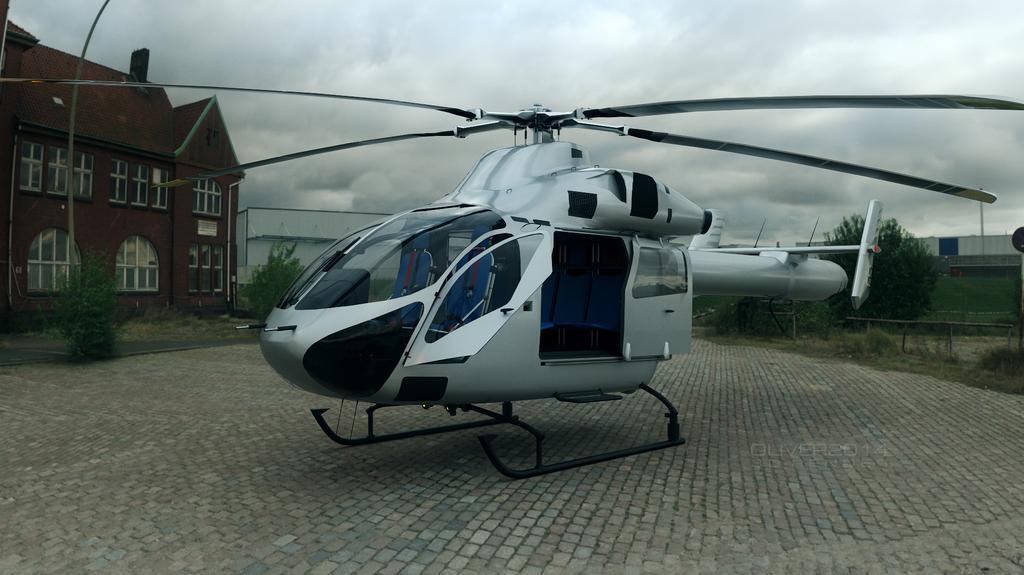Can you describe this image briefly? In this image I can see a helicopter which is white, black and blue in color on the ground. In the background I can see few buildings, few trees and the sky. 